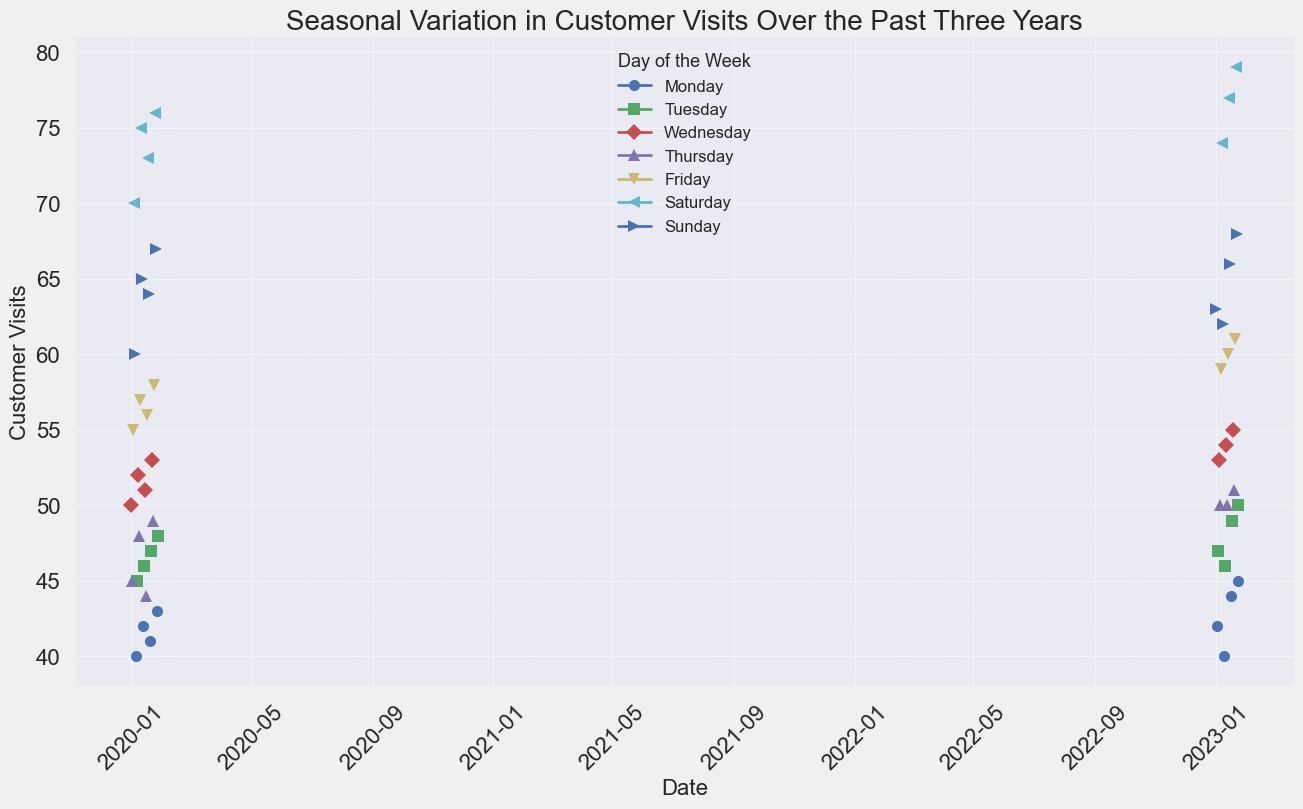How does customer traffic vary by day of the week? The line chart uses different markers to represent each day of the week. By examining the pattern of each line, we can observe that Saturdays usually have the highest number of customer visits, while Mondays have the lowest customer visits.
Answer: Saturdays have the highest, and Mondays have the lowest Which day of the week saw the highest peak in customer visits over the past three years? We need to look for the highest point among all the lines. The highest peak appears to be on a Saturday, specifically around 76-79 customer visits. This visual assessment is based on the line's peak for Saturdays.
Answer: Saturday On average, which day of the week has the most customer visits? We can average the daily visits by observing the general trend of each line. The Saturday line appears to consistently have higher visit numbers compared to other days.
Answer: Saturday Are there any days that show a notable increase or decrease during the past three years? Visually assess the trend lines for any abrupt changes. Wednesdays and Thursdays show smaller fluctuations, whereas Saturdays consistently increase over time.
Answer: Saturdays show a notable increase Which day of the week has the most consistent customer visits? Consistency can be seen in the lines that have the least fluctuation. Observing the chart, Monday’s line is relatively flat compared to other days, indicating more consistent visits.
Answer: Monday How do customer visits on Fridays compare to those on Sundays? Comparing the Friday and Sunday lines, we see that Fridays start a bit lower than Sundays but generally climb close to Sunday’s values by the end of the period.
Answer: Fridays and Sundays are comparable in the later period What month shows the highest overall customer visits for weekdays? Sum the heights of the lines for Monday through Friday for each month. From visual inspection, months around mid-year (June/July) appear higher for these days compared to others.
Answer: June/July During the last year shown, which weekday had the steepest increase in visits from the previous years? Look for a sharp slope increase in the last segment of each line. Fridays show a steeper increase in visits, indicating a notable rise in customer visits compared to previous years.
Answer: Friday What is the difference in customer visits between the highest Saturday and the lowest Monday? Identify the highest Saturday peak (79) and the lowest Monday point (40). Subtracting the lowest Monday from the highest Saturday gives 79 - 40.
Answer: 39 In which season do we see the highest peaks in customer visits across all days? Look for the highest peaks in the line chart, noting their date. The peaks mainly occur during the summer months (June-August).
Answer: Summer 